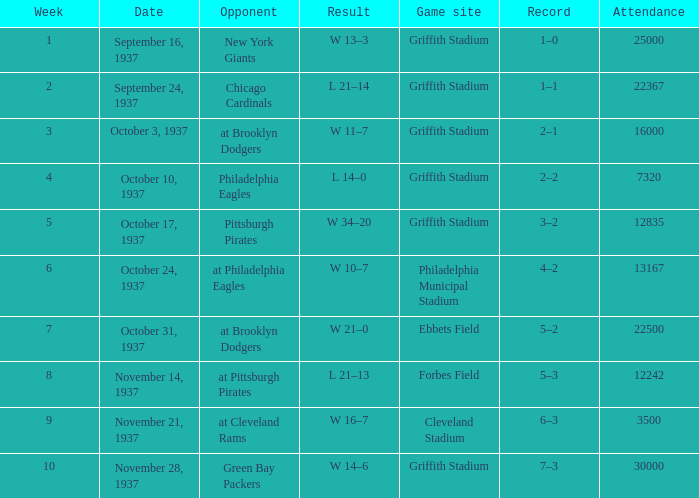In week 9 who were the opponent?  At cleveland rams. 